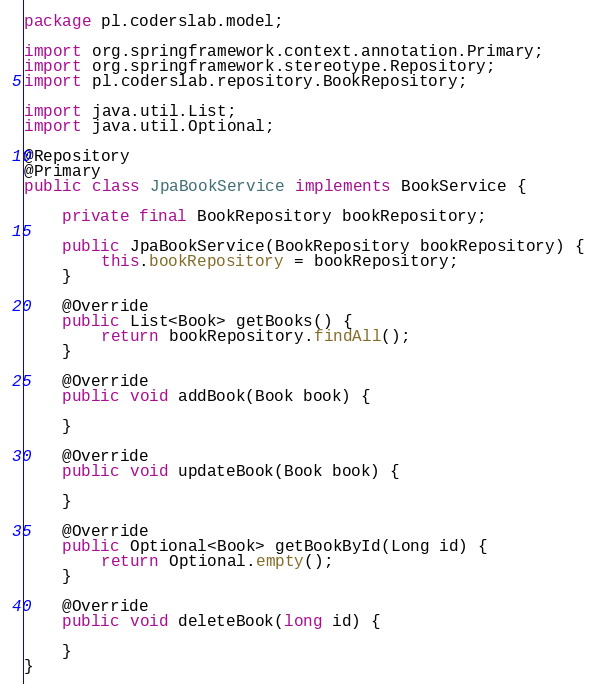<code> <loc_0><loc_0><loc_500><loc_500><_Java_>package pl.coderslab.model;

import org.springframework.context.annotation.Primary;
import org.springframework.stereotype.Repository;
import pl.coderslab.repository.BookRepository;

import java.util.List;
import java.util.Optional;

@Repository
@Primary
public class JpaBookService implements BookService {

    private final BookRepository bookRepository;

    public JpaBookService(BookRepository bookRepository) {
        this.bookRepository = bookRepository;
    }

    @Override
    public List<Book> getBooks() {
        return bookRepository.findAll();
    }

    @Override
    public void addBook(Book book) {

    }

    @Override
    public void updateBook(Book book) {

    }

    @Override
    public Optional<Book> getBookById(Long id) {
        return Optional.empty();
    }

    @Override
    public void deleteBook(long id) {

    }
}
</code> 